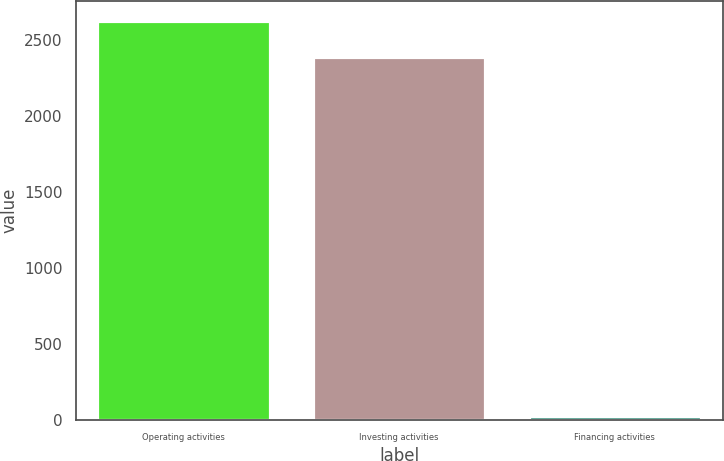Convert chart to OTSL. <chart><loc_0><loc_0><loc_500><loc_500><bar_chart><fcel>Operating activities<fcel>Investing activities<fcel>Financing activities<nl><fcel>2626.31<fcel>2384.4<fcel>26.4<nl></chart> 